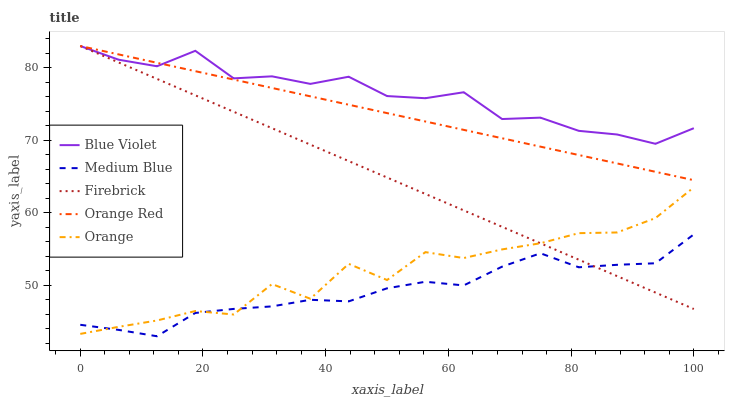Does Medium Blue have the minimum area under the curve?
Answer yes or no. Yes. Does Blue Violet have the maximum area under the curve?
Answer yes or no. Yes. Does Firebrick have the minimum area under the curve?
Answer yes or no. No. Does Firebrick have the maximum area under the curve?
Answer yes or no. No. Is Firebrick the smoothest?
Answer yes or no. Yes. Is Orange the roughest?
Answer yes or no. Yes. Is Medium Blue the smoothest?
Answer yes or no. No. Is Medium Blue the roughest?
Answer yes or no. No. Does Medium Blue have the lowest value?
Answer yes or no. Yes. Does Firebrick have the lowest value?
Answer yes or no. No. Does Blue Violet have the highest value?
Answer yes or no. Yes. Does Medium Blue have the highest value?
Answer yes or no. No. Is Orange less than Orange Red?
Answer yes or no. Yes. Is Blue Violet greater than Orange?
Answer yes or no. Yes. Does Firebrick intersect Blue Violet?
Answer yes or no. Yes. Is Firebrick less than Blue Violet?
Answer yes or no. No. Is Firebrick greater than Blue Violet?
Answer yes or no. No. Does Orange intersect Orange Red?
Answer yes or no. No. 